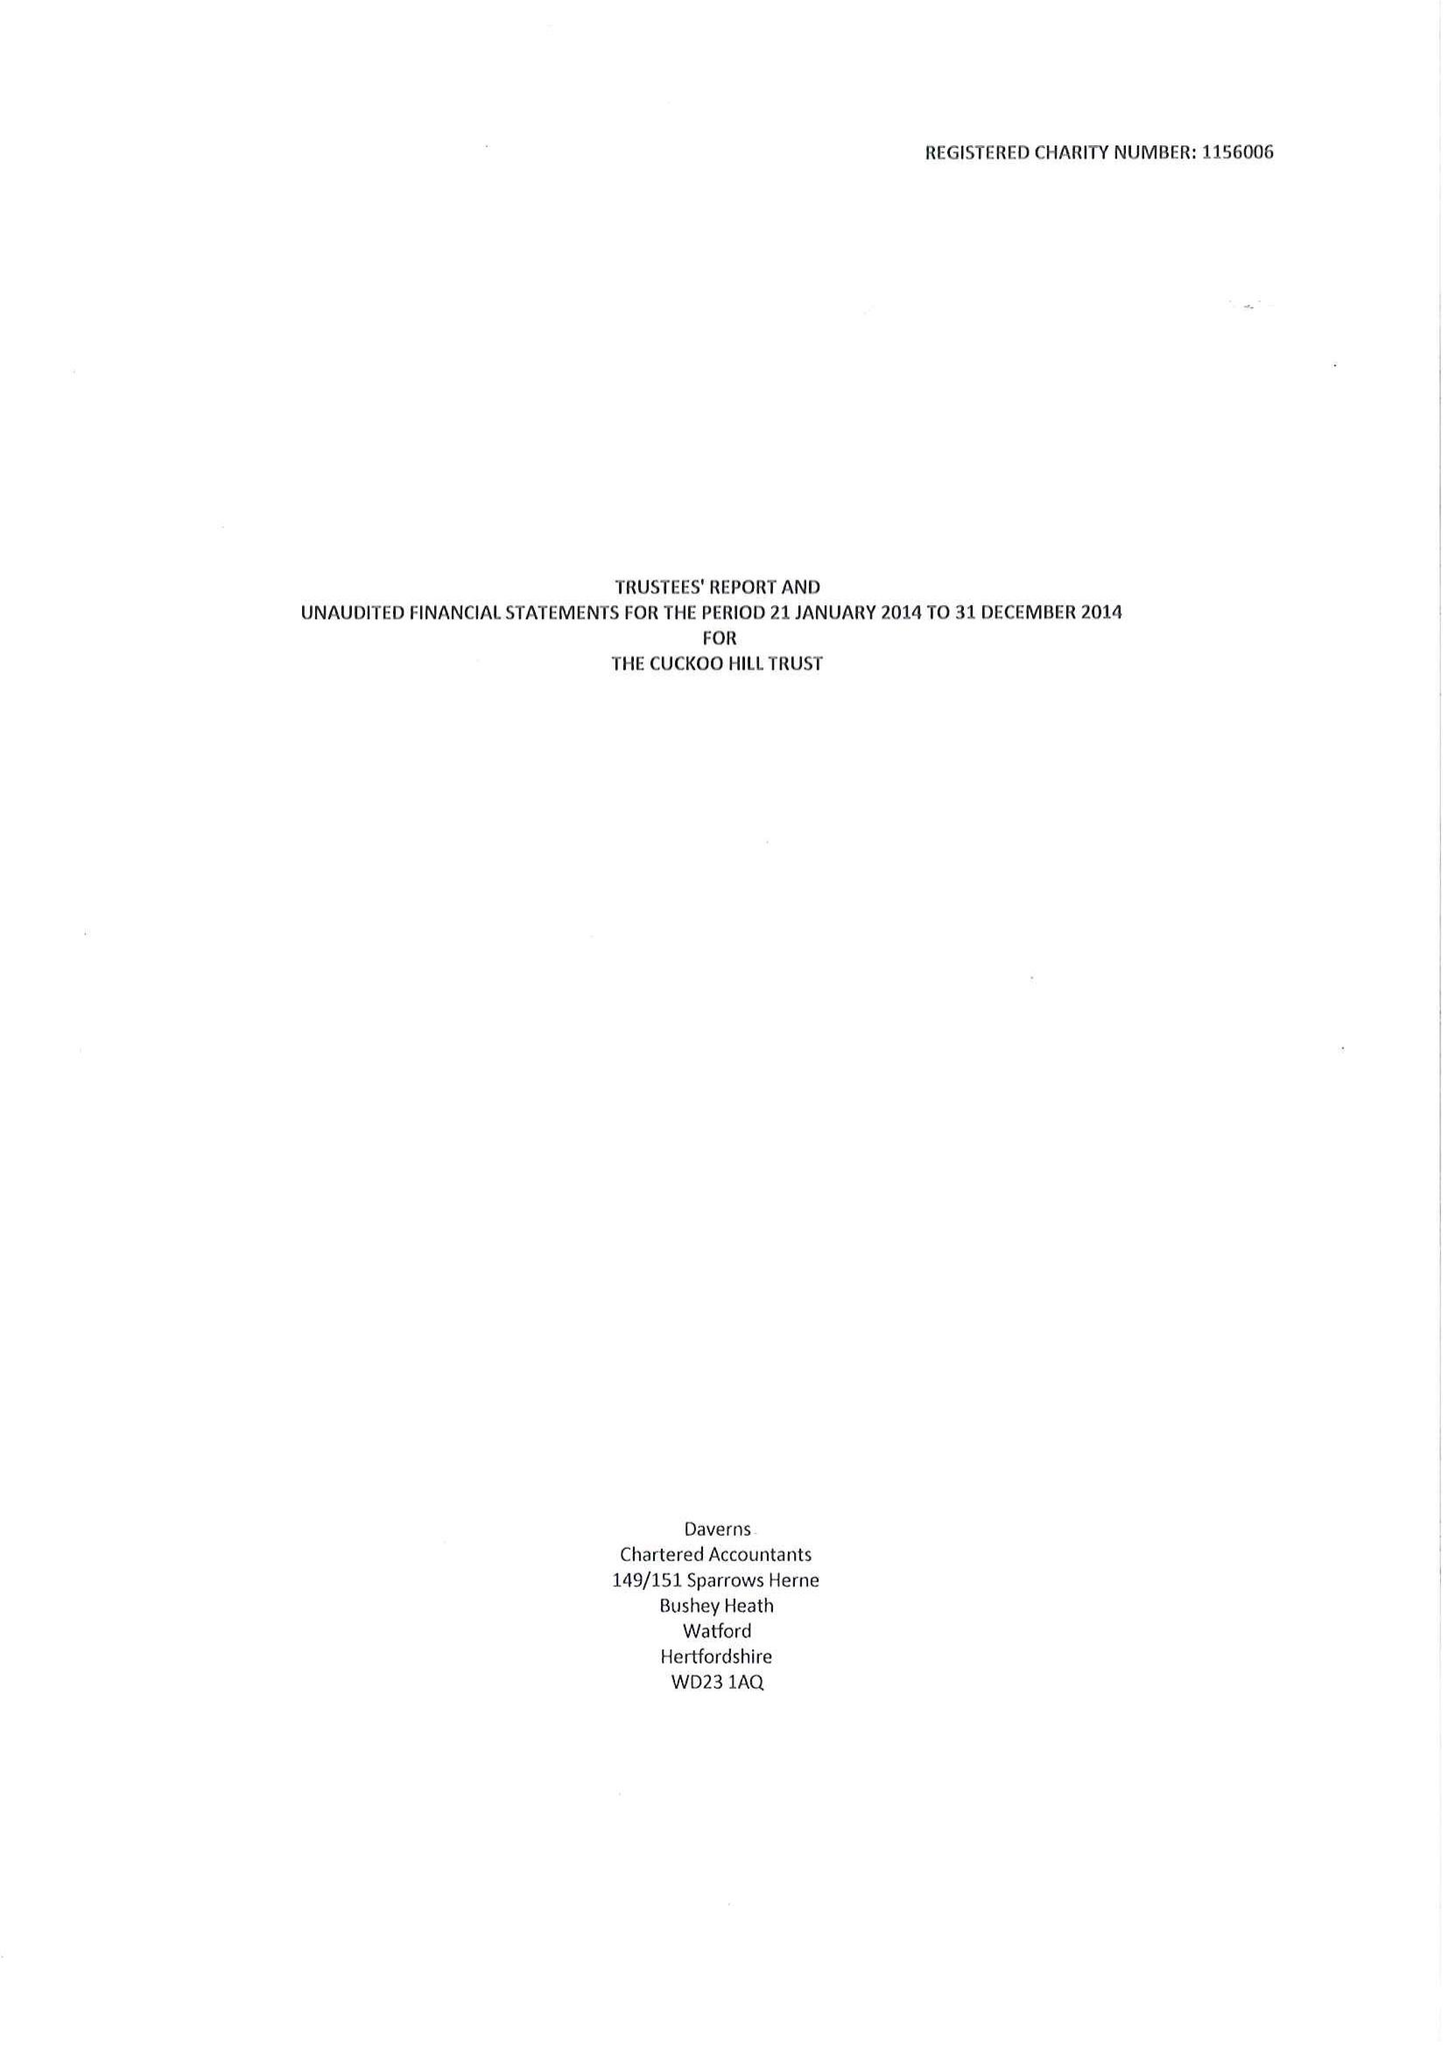What is the value for the address__street_line?
Answer the question using a single word or phrase. CUCKOO HILL 